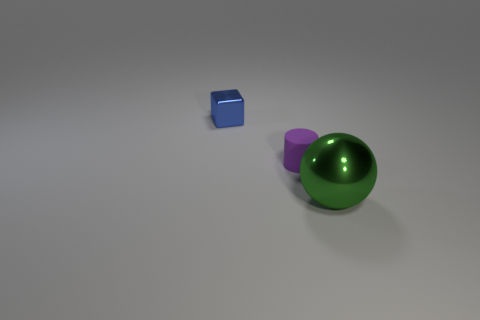Is there any other thing that is the same material as the purple cylinder?
Offer a terse response. No. Is the purple rubber cylinder the same size as the green metal ball?
Give a very brief answer. No. How many rubber objects are the same size as the green metal sphere?
Provide a short and direct response. 0. There is a large ball that is the same material as the blue cube; what color is it?
Ensure brevity in your answer.  Green. Is the number of big metallic spheres less than the number of large blue cylinders?
Offer a very short reply. No. What number of red objects are either rubber things or tiny things?
Make the answer very short. 0. What number of things are right of the small blue object and behind the green sphere?
Provide a short and direct response. 1. Do the small cylinder and the green sphere have the same material?
Ensure brevity in your answer.  No. There is a shiny object that is the same size as the matte cylinder; what is its shape?
Make the answer very short. Cube. Is the number of small brown metal spheres greater than the number of tiny purple things?
Offer a terse response. No. 